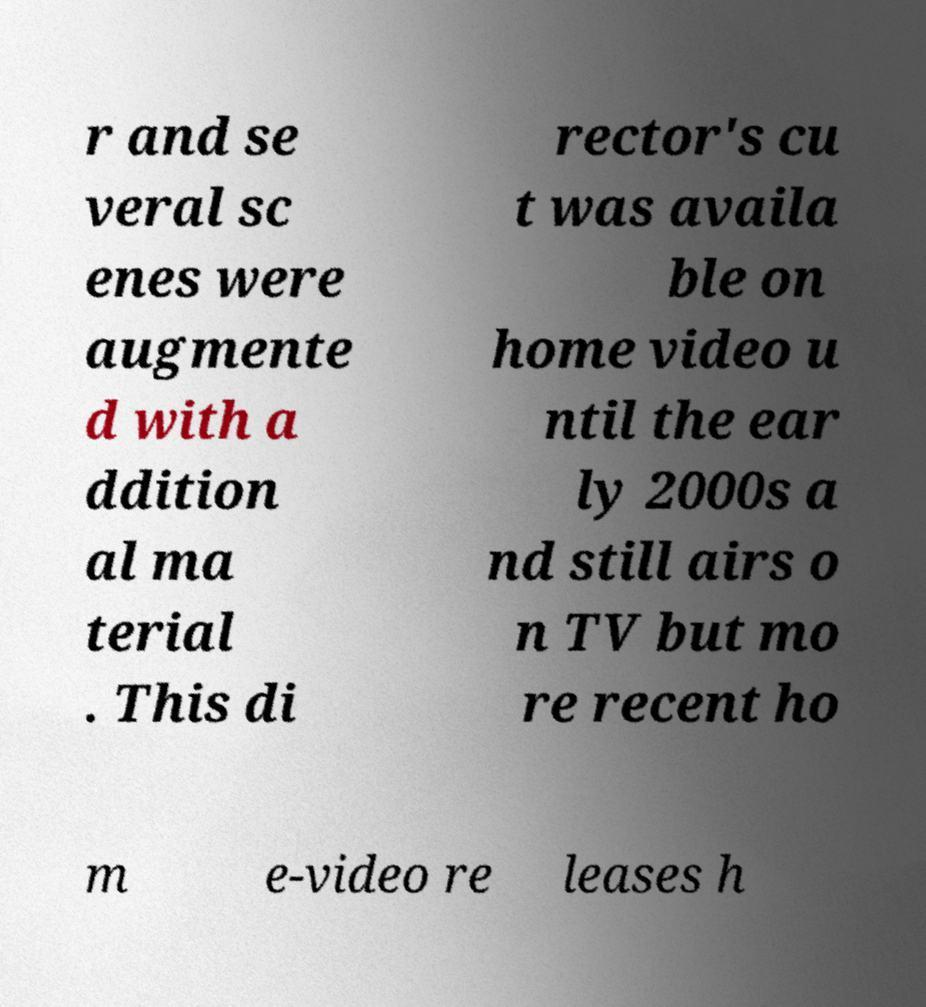For documentation purposes, I need the text within this image transcribed. Could you provide that? r and se veral sc enes were augmente d with a ddition al ma terial . This di rector's cu t was availa ble on home video u ntil the ear ly 2000s a nd still airs o n TV but mo re recent ho m e-video re leases h 